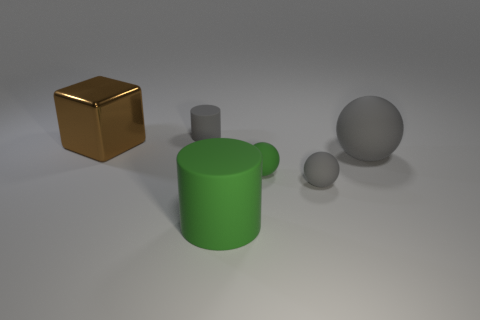What are the colors of the various objects in the scene? The objects present display an array of colors: the cube is golden brown with a shiny surface, the cylinder and mug are matte green, and the spheres come in matte gray and a reflective silver, showing the diversity of textures and colors in this image. 